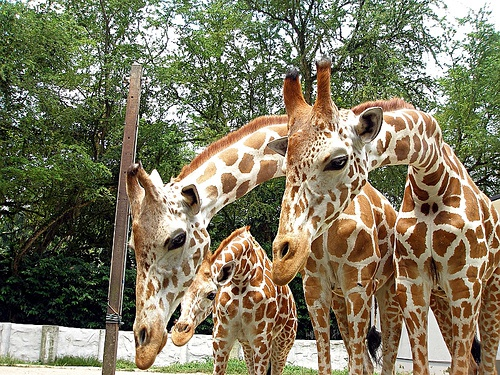Describe the objects in this image and their specific colors. I can see giraffe in lightblue, maroon, ivory, and tan tones, giraffe in lightblue, ivory, maroon, and tan tones, and giraffe in lightblue, maroon, ivory, tan, and gray tones in this image. 